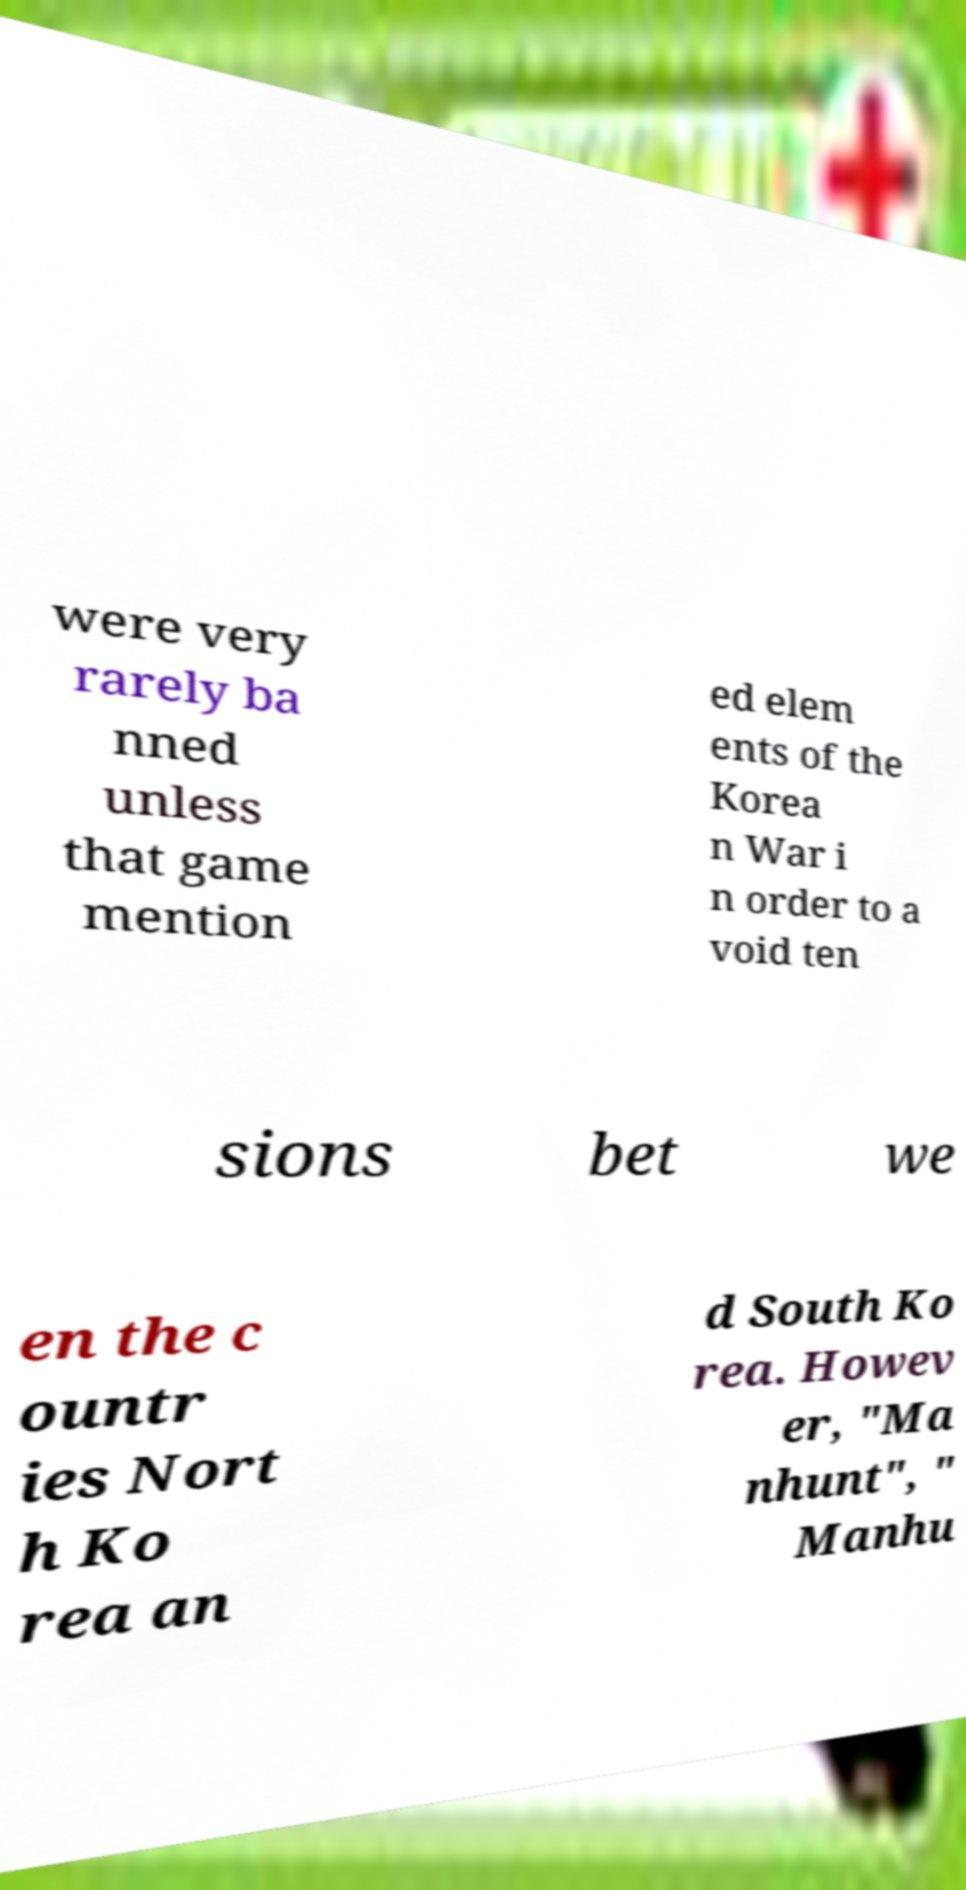Can you accurately transcribe the text from the provided image for me? were very rarely ba nned unless that game mention ed elem ents of the Korea n War i n order to a void ten sions bet we en the c ountr ies Nort h Ko rea an d South Ko rea. Howev er, "Ma nhunt", " Manhu 